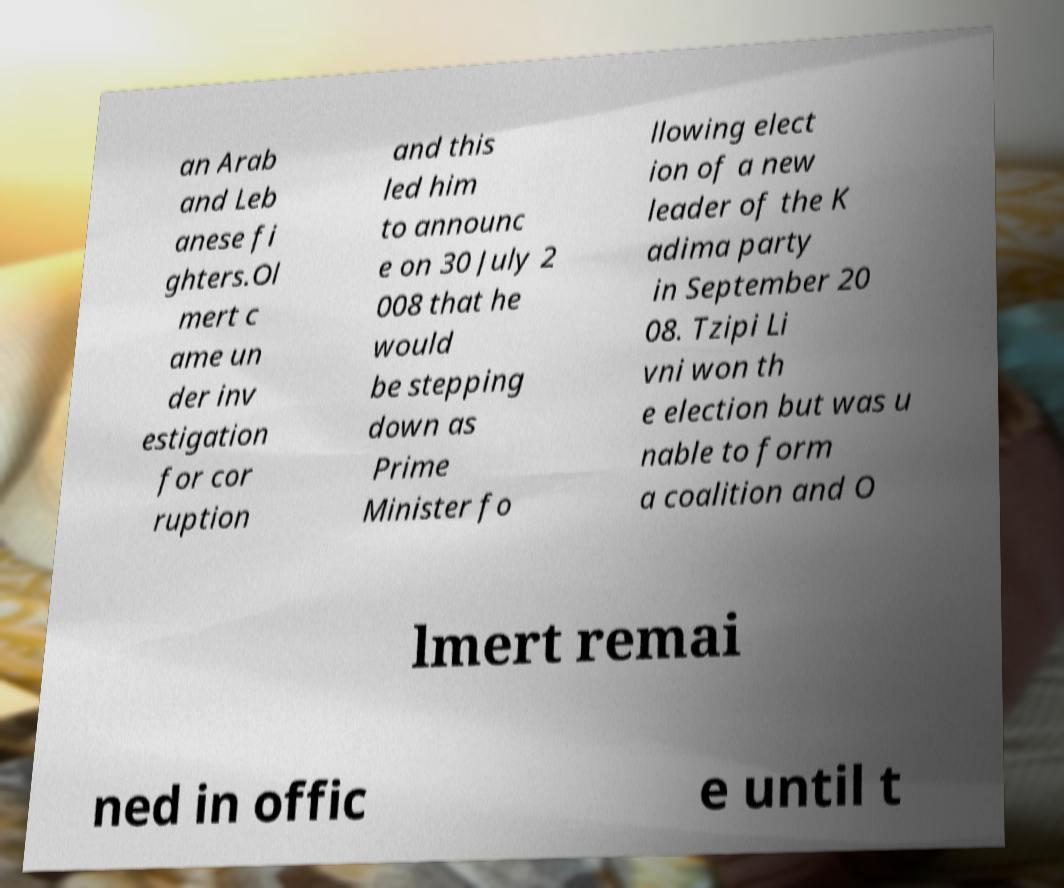Can you accurately transcribe the text from the provided image for me? an Arab and Leb anese fi ghters.Ol mert c ame un der inv estigation for cor ruption and this led him to announc e on 30 July 2 008 that he would be stepping down as Prime Minister fo llowing elect ion of a new leader of the K adima party in September 20 08. Tzipi Li vni won th e election but was u nable to form a coalition and O lmert remai ned in offic e until t 